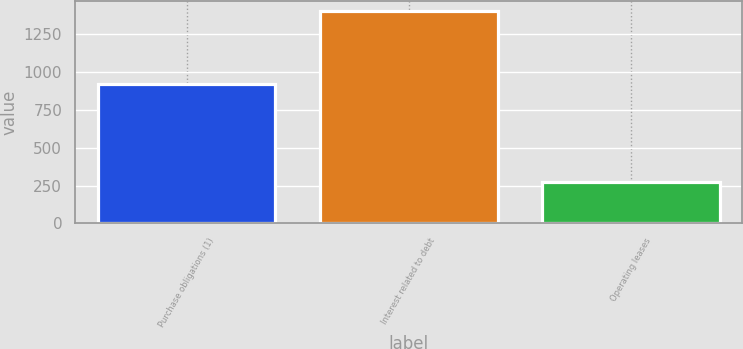<chart> <loc_0><loc_0><loc_500><loc_500><bar_chart><fcel>Purchase obligations (1)<fcel>Interest related to debt<fcel>Operating leases<nl><fcel>922<fcel>1399<fcel>276<nl></chart> 